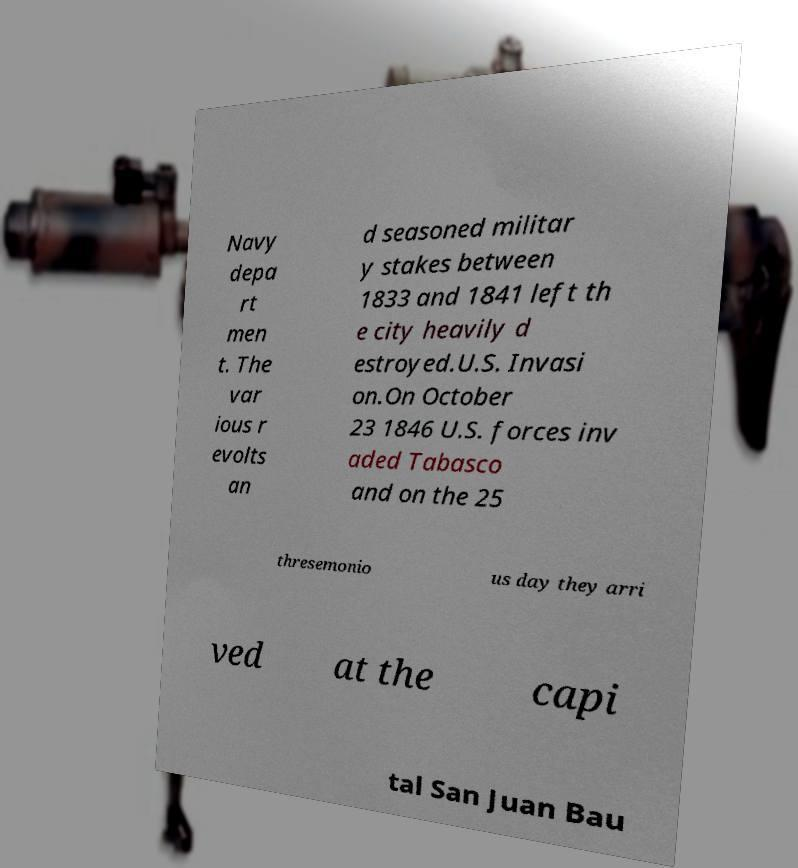What messages or text are displayed in this image? I need them in a readable, typed format. Navy depa rt men t. The var ious r evolts an d seasoned militar y stakes between 1833 and 1841 left th e city heavily d estroyed.U.S. Invasi on.On October 23 1846 U.S. forces inv aded Tabasco and on the 25 thresemonio us day they arri ved at the capi tal San Juan Bau 